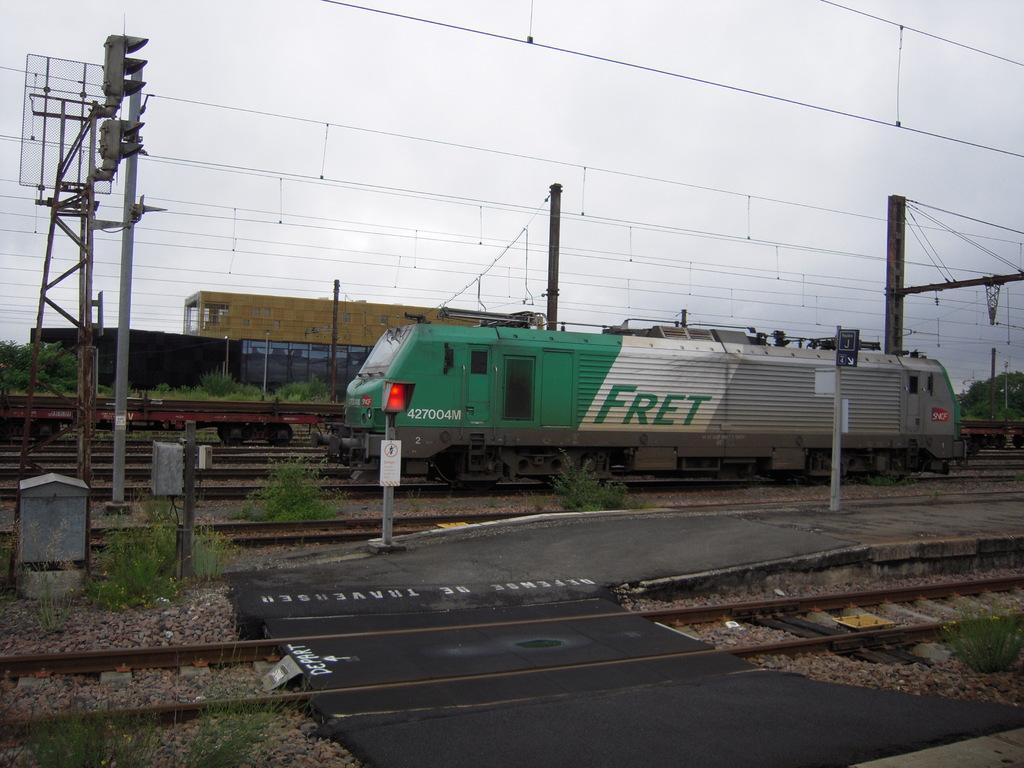<image>
Present a compact description of the photo's key features. A green, white and gray train with the text fret on the middle white section. 